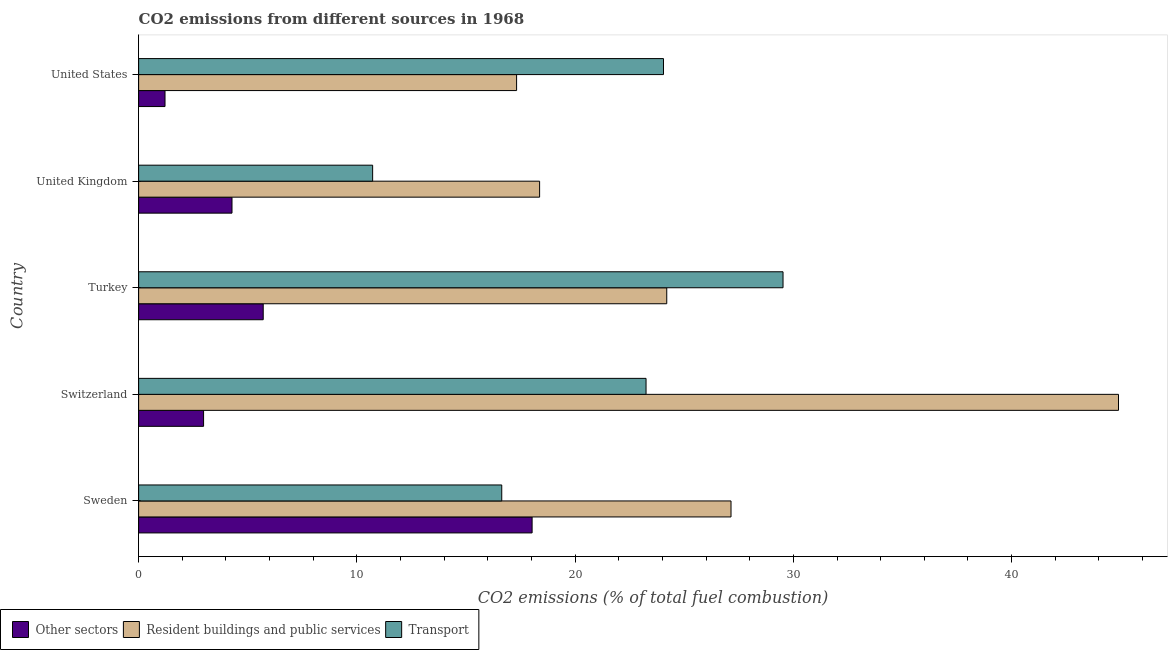Are the number of bars per tick equal to the number of legend labels?
Your answer should be very brief. Yes. What is the label of the 4th group of bars from the top?
Your answer should be compact. Switzerland. What is the percentage of co2 emissions from transport in United Kingdom?
Your response must be concise. 10.72. Across all countries, what is the maximum percentage of co2 emissions from transport?
Ensure brevity in your answer.  29.53. Across all countries, what is the minimum percentage of co2 emissions from other sectors?
Provide a succinct answer. 1.21. In which country was the percentage of co2 emissions from resident buildings and public services maximum?
Your answer should be compact. Switzerland. In which country was the percentage of co2 emissions from other sectors minimum?
Your response must be concise. United States. What is the total percentage of co2 emissions from other sectors in the graph?
Your answer should be compact. 32.2. What is the difference between the percentage of co2 emissions from transport in Turkey and that in United States?
Ensure brevity in your answer.  5.48. What is the difference between the percentage of co2 emissions from resident buildings and public services in Turkey and the percentage of co2 emissions from other sectors in United States?
Provide a short and direct response. 22.99. What is the average percentage of co2 emissions from resident buildings and public services per country?
Offer a terse response. 26.39. What is the difference between the percentage of co2 emissions from other sectors and percentage of co2 emissions from resident buildings and public services in Turkey?
Provide a succinct answer. -18.49. In how many countries, is the percentage of co2 emissions from transport greater than 26 %?
Keep it short and to the point. 1. What is the ratio of the percentage of co2 emissions from other sectors in Sweden to that in United Kingdom?
Make the answer very short. 4.21. Is the percentage of co2 emissions from transport in Sweden less than that in United States?
Your response must be concise. Yes. Is the difference between the percentage of co2 emissions from transport in Sweden and United States greater than the difference between the percentage of co2 emissions from other sectors in Sweden and United States?
Keep it short and to the point. No. What is the difference between the highest and the second highest percentage of co2 emissions from resident buildings and public services?
Offer a terse response. 17.75. What is the difference between the highest and the lowest percentage of co2 emissions from resident buildings and public services?
Offer a terse response. 27.58. In how many countries, is the percentage of co2 emissions from other sectors greater than the average percentage of co2 emissions from other sectors taken over all countries?
Offer a very short reply. 1. What does the 2nd bar from the top in Turkey represents?
Offer a very short reply. Resident buildings and public services. What does the 1st bar from the bottom in United States represents?
Keep it short and to the point. Other sectors. Is it the case that in every country, the sum of the percentage of co2 emissions from other sectors and percentage of co2 emissions from resident buildings and public services is greater than the percentage of co2 emissions from transport?
Your answer should be compact. No. How many bars are there?
Keep it short and to the point. 15. How are the legend labels stacked?
Provide a short and direct response. Horizontal. What is the title of the graph?
Your answer should be compact. CO2 emissions from different sources in 1968. Does "Natural gas sources" appear as one of the legend labels in the graph?
Keep it short and to the point. No. What is the label or title of the X-axis?
Ensure brevity in your answer.  CO2 emissions (% of total fuel combustion). What is the CO2 emissions (% of total fuel combustion) in Other sectors in Sweden?
Your answer should be compact. 18.03. What is the CO2 emissions (% of total fuel combustion) of Resident buildings and public services in Sweden?
Give a very brief answer. 27.14. What is the CO2 emissions (% of total fuel combustion) in Transport in Sweden?
Make the answer very short. 16.64. What is the CO2 emissions (% of total fuel combustion) of Other sectors in Switzerland?
Ensure brevity in your answer.  2.98. What is the CO2 emissions (% of total fuel combustion) of Resident buildings and public services in Switzerland?
Provide a short and direct response. 44.9. What is the CO2 emissions (% of total fuel combustion) of Transport in Switzerland?
Make the answer very short. 23.25. What is the CO2 emissions (% of total fuel combustion) in Other sectors in Turkey?
Your answer should be very brief. 5.71. What is the CO2 emissions (% of total fuel combustion) of Resident buildings and public services in Turkey?
Give a very brief answer. 24.2. What is the CO2 emissions (% of total fuel combustion) in Transport in Turkey?
Your answer should be very brief. 29.53. What is the CO2 emissions (% of total fuel combustion) in Other sectors in United Kingdom?
Provide a short and direct response. 4.28. What is the CO2 emissions (% of total fuel combustion) of Resident buildings and public services in United Kingdom?
Provide a short and direct response. 18.37. What is the CO2 emissions (% of total fuel combustion) in Transport in United Kingdom?
Provide a succinct answer. 10.72. What is the CO2 emissions (% of total fuel combustion) in Other sectors in United States?
Make the answer very short. 1.21. What is the CO2 emissions (% of total fuel combustion) in Resident buildings and public services in United States?
Ensure brevity in your answer.  17.32. What is the CO2 emissions (% of total fuel combustion) of Transport in United States?
Offer a terse response. 24.05. Across all countries, what is the maximum CO2 emissions (% of total fuel combustion) in Other sectors?
Provide a succinct answer. 18.03. Across all countries, what is the maximum CO2 emissions (% of total fuel combustion) of Resident buildings and public services?
Your answer should be very brief. 44.9. Across all countries, what is the maximum CO2 emissions (% of total fuel combustion) in Transport?
Offer a terse response. 29.53. Across all countries, what is the minimum CO2 emissions (% of total fuel combustion) in Other sectors?
Offer a terse response. 1.21. Across all countries, what is the minimum CO2 emissions (% of total fuel combustion) in Resident buildings and public services?
Make the answer very short. 17.32. Across all countries, what is the minimum CO2 emissions (% of total fuel combustion) in Transport?
Keep it short and to the point. 10.72. What is the total CO2 emissions (% of total fuel combustion) of Other sectors in the graph?
Keep it short and to the point. 32.2. What is the total CO2 emissions (% of total fuel combustion) of Resident buildings and public services in the graph?
Keep it short and to the point. 131.93. What is the total CO2 emissions (% of total fuel combustion) of Transport in the graph?
Provide a short and direct response. 104.19. What is the difference between the CO2 emissions (% of total fuel combustion) in Other sectors in Sweden and that in Switzerland?
Your answer should be very brief. 15.05. What is the difference between the CO2 emissions (% of total fuel combustion) in Resident buildings and public services in Sweden and that in Switzerland?
Your answer should be very brief. -17.75. What is the difference between the CO2 emissions (% of total fuel combustion) of Transport in Sweden and that in Switzerland?
Offer a very short reply. -6.61. What is the difference between the CO2 emissions (% of total fuel combustion) of Other sectors in Sweden and that in Turkey?
Provide a short and direct response. 12.32. What is the difference between the CO2 emissions (% of total fuel combustion) of Resident buildings and public services in Sweden and that in Turkey?
Give a very brief answer. 2.94. What is the difference between the CO2 emissions (% of total fuel combustion) of Transport in Sweden and that in Turkey?
Make the answer very short. -12.89. What is the difference between the CO2 emissions (% of total fuel combustion) in Other sectors in Sweden and that in United Kingdom?
Your response must be concise. 13.75. What is the difference between the CO2 emissions (% of total fuel combustion) of Resident buildings and public services in Sweden and that in United Kingdom?
Make the answer very short. 8.77. What is the difference between the CO2 emissions (% of total fuel combustion) of Transport in Sweden and that in United Kingdom?
Your response must be concise. 5.92. What is the difference between the CO2 emissions (% of total fuel combustion) in Other sectors in Sweden and that in United States?
Offer a terse response. 16.82. What is the difference between the CO2 emissions (% of total fuel combustion) in Resident buildings and public services in Sweden and that in United States?
Your response must be concise. 9.82. What is the difference between the CO2 emissions (% of total fuel combustion) in Transport in Sweden and that in United States?
Your answer should be compact. -7.41. What is the difference between the CO2 emissions (% of total fuel combustion) of Other sectors in Switzerland and that in Turkey?
Your answer should be compact. -2.73. What is the difference between the CO2 emissions (% of total fuel combustion) in Resident buildings and public services in Switzerland and that in Turkey?
Ensure brevity in your answer.  20.7. What is the difference between the CO2 emissions (% of total fuel combustion) in Transport in Switzerland and that in Turkey?
Your answer should be compact. -6.28. What is the difference between the CO2 emissions (% of total fuel combustion) in Other sectors in Switzerland and that in United Kingdom?
Provide a short and direct response. -1.3. What is the difference between the CO2 emissions (% of total fuel combustion) in Resident buildings and public services in Switzerland and that in United Kingdom?
Give a very brief answer. 26.52. What is the difference between the CO2 emissions (% of total fuel combustion) in Transport in Switzerland and that in United Kingdom?
Offer a very short reply. 12.53. What is the difference between the CO2 emissions (% of total fuel combustion) of Other sectors in Switzerland and that in United States?
Offer a terse response. 1.77. What is the difference between the CO2 emissions (% of total fuel combustion) in Resident buildings and public services in Switzerland and that in United States?
Offer a terse response. 27.58. What is the difference between the CO2 emissions (% of total fuel combustion) in Transport in Switzerland and that in United States?
Your answer should be very brief. -0.8. What is the difference between the CO2 emissions (% of total fuel combustion) in Other sectors in Turkey and that in United Kingdom?
Provide a short and direct response. 1.43. What is the difference between the CO2 emissions (% of total fuel combustion) in Resident buildings and public services in Turkey and that in United Kingdom?
Keep it short and to the point. 5.83. What is the difference between the CO2 emissions (% of total fuel combustion) in Transport in Turkey and that in United Kingdom?
Provide a short and direct response. 18.8. What is the difference between the CO2 emissions (% of total fuel combustion) in Other sectors in Turkey and that in United States?
Provide a short and direct response. 4.5. What is the difference between the CO2 emissions (% of total fuel combustion) of Resident buildings and public services in Turkey and that in United States?
Provide a succinct answer. 6.88. What is the difference between the CO2 emissions (% of total fuel combustion) in Transport in Turkey and that in United States?
Make the answer very short. 5.48. What is the difference between the CO2 emissions (% of total fuel combustion) in Other sectors in United Kingdom and that in United States?
Your response must be concise. 3.07. What is the difference between the CO2 emissions (% of total fuel combustion) in Resident buildings and public services in United Kingdom and that in United States?
Provide a short and direct response. 1.05. What is the difference between the CO2 emissions (% of total fuel combustion) of Transport in United Kingdom and that in United States?
Your answer should be very brief. -13.33. What is the difference between the CO2 emissions (% of total fuel combustion) of Other sectors in Sweden and the CO2 emissions (% of total fuel combustion) of Resident buildings and public services in Switzerland?
Your answer should be compact. -26.87. What is the difference between the CO2 emissions (% of total fuel combustion) of Other sectors in Sweden and the CO2 emissions (% of total fuel combustion) of Transport in Switzerland?
Your answer should be very brief. -5.22. What is the difference between the CO2 emissions (% of total fuel combustion) of Resident buildings and public services in Sweden and the CO2 emissions (% of total fuel combustion) of Transport in Switzerland?
Offer a very short reply. 3.89. What is the difference between the CO2 emissions (% of total fuel combustion) in Other sectors in Sweden and the CO2 emissions (% of total fuel combustion) in Resident buildings and public services in Turkey?
Make the answer very short. -6.17. What is the difference between the CO2 emissions (% of total fuel combustion) of Other sectors in Sweden and the CO2 emissions (% of total fuel combustion) of Transport in Turkey?
Your response must be concise. -11.5. What is the difference between the CO2 emissions (% of total fuel combustion) of Resident buildings and public services in Sweden and the CO2 emissions (% of total fuel combustion) of Transport in Turkey?
Your response must be concise. -2.38. What is the difference between the CO2 emissions (% of total fuel combustion) of Other sectors in Sweden and the CO2 emissions (% of total fuel combustion) of Resident buildings and public services in United Kingdom?
Offer a terse response. -0.34. What is the difference between the CO2 emissions (% of total fuel combustion) in Other sectors in Sweden and the CO2 emissions (% of total fuel combustion) in Transport in United Kingdom?
Provide a short and direct response. 7.31. What is the difference between the CO2 emissions (% of total fuel combustion) of Resident buildings and public services in Sweden and the CO2 emissions (% of total fuel combustion) of Transport in United Kingdom?
Ensure brevity in your answer.  16.42. What is the difference between the CO2 emissions (% of total fuel combustion) of Other sectors in Sweden and the CO2 emissions (% of total fuel combustion) of Resident buildings and public services in United States?
Ensure brevity in your answer.  0.71. What is the difference between the CO2 emissions (% of total fuel combustion) of Other sectors in Sweden and the CO2 emissions (% of total fuel combustion) of Transport in United States?
Provide a succinct answer. -6.02. What is the difference between the CO2 emissions (% of total fuel combustion) in Resident buildings and public services in Sweden and the CO2 emissions (% of total fuel combustion) in Transport in United States?
Provide a succinct answer. 3.09. What is the difference between the CO2 emissions (% of total fuel combustion) in Other sectors in Switzerland and the CO2 emissions (% of total fuel combustion) in Resident buildings and public services in Turkey?
Give a very brief answer. -21.22. What is the difference between the CO2 emissions (% of total fuel combustion) in Other sectors in Switzerland and the CO2 emissions (% of total fuel combustion) in Transport in Turkey?
Keep it short and to the point. -26.55. What is the difference between the CO2 emissions (% of total fuel combustion) of Resident buildings and public services in Switzerland and the CO2 emissions (% of total fuel combustion) of Transport in Turkey?
Offer a terse response. 15.37. What is the difference between the CO2 emissions (% of total fuel combustion) in Other sectors in Switzerland and the CO2 emissions (% of total fuel combustion) in Resident buildings and public services in United Kingdom?
Your response must be concise. -15.4. What is the difference between the CO2 emissions (% of total fuel combustion) in Other sectors in Switzerland and the CO2 emissions (% of total fuel combustion) in Transport in United Kingdom?
Keep it short and to the point. -7.75. What is the difference between the CO2 emissions (% of total fuel combustion) of Resident buildings and public services in Switzerland and the CO2 emissions (% of total fuel combustion) of Transport in United Kingdom?
Keep it short and to the point. 34.18. What is the difference between the CO2 emissions (% of total fuel combustion) in Other sectors in Switzerland and the CO2 emissions (% of total fuel combustion) in Resident buildings and public services in United States?
Provide a short and direct response. -14.34. What is the difference between the CO2 emissions (% of total fuel combustion) in Other sectors in Switzerland and the CO2 emissions (% of total fuel combustion) in Transport in United States?
Your answer should be very brief. -21.07. What is the difference between the CO2 emissions (% of total fuel combustion) in Resident buildings and public services in Switzerland and the CO2 emissions (% of total fuel combustion) in Transport in United States?
Offer a terse response. 20.85. What is the difference between the CO2 emissions (% of total fuel combustion) in Other sectors in Turkey and the CO2 emissions (% of total fuel combustion) in Resident buildings and public services in United Kingdom?
Provide a succinct answer. -12.66. What is the difference between the CO2 emissions (% of total fuel combustion) of Other sectors in Turkey and the CO2 emissions (% of total fuel combustion) of Transport in United Kingdom?
Offer a terse response. -5.01. What is the difference between the CO2 emissions (% of total fuel combustion) in Resident buildings and public services in Turkey and the CO2 emissions (% of total fuel combustion) in Transport in United Kingdom?
Provide a succinct answer. 13.48. What is the difference between the CO2 emissions (% of total fuel combustion) in Other sectors in Turkey and the CO2 emissions (% of total fuel combustion) in Resident buildings and public services in United States?
Keep it short and to the point. -11.61. What is the difference between the CO2 emissions (% of total fuel combustion) of Other sectors in Turkey and the CO2 emissions (% of total fuel combustion) of Transport in United States?
Your answer should be compact. -18.34. What is the difference between the CO2 emissions (% of total fuel combustion) in Resident buildings and public services in Turkey and the CO2 emissions (% of total fuel combustion) in Transport in United States?
Ensure brevity in your answer.  0.15. What is the difference between the CO2 emissions (% of total fuel combustion) in Other sectors in United Kingdom and the CO2 emissions (% of total fuel combustion) in Resident buildings and public services in United States?
Offer a terse response. -13.04. What is the difference between the CO2 emissions (% of total fuel combustion) in Other sectors in United Kingdom and the CO2 emissions (% of total fuel combustion) in Transport in United States?
Your answer should be compact. -19.77. What is the difference between the CO2 emissions (% of total fuel combustion) of Resident buildings and public services in United Kingdom and the CO2 emissions (% of total fuel combustion) of Transport in United States?
Your answer should be compact. -5.68. What is the average CO2 emissions (% of total fuel combustion) in Other sectors per country?
Offer a terse response. 6.44. What is the average CO2 emissions (% of total fuel combustion) of Resident buildings and public services per country?
Offer a very short reply. 26.39. What is the average CO2 emissions (% of total fuel combustion) in Transport per country?
Provide a short and direct response. 20.84. What is the difference between the CO2 emissions (% of total fuel combustion) in Other sectors and CO2 emissions (% of total fuel combustion) in Resident buildings and public services in Sweden?
Provide a succinct answer. -9.11. What is the difference between the CO2 emissions (% of total fuel combustion) of Other sectors and CO2 emissions (% of total fuel combustion) of Transport in Sweden?
Provide a short and direct response. 1.39. What is the difference between the CO2 emissions (% of total fuel combustion) in Resident buildings and public services and CO2 emissions (% of total fuel combustion) in Transport in Sweden?
Offer a terse response. 10.51. What is the difference between the CO2 emissions (% of total fuel combustion) of Other sectors and CO2 emissions (% of total fuel combustion) of Resident buildings and public services in Switzerland?
Give a very brief answer. -41.92. What is the difference between the CO2 emissions (% of total fuel combustion) of Other sectors and CO2 emissions (% of total fuel combustion) of Transport in Switzerland?
Your response must be concise. -20.27. What is the difference between the CO2 emissions (% of total fuel combustion) of Resident buildings and public services and CO2 emissions (% of total fuel combustion) of Transport in Switzerland?
Provide a short and direct response. 21.65. What is the difference between the CO2 emissions (% of total fuel combustion) of Other sectors and CO2 emissions (% of total fuel combustion) of Resident buildings and public services in Turkey?
Your answer should be compact. -18.49. What is the difference between the CO2 emissions (% of total fuel combustion) of Other sectors and CO2 emissions (% of total fuel combustion) of Transport in Turkey?
Your answer should be compact. -23.82. What is the difference between the CO2 emissions (% of total fuel combustion) in Resident buildings and public services and CO2 emissions (% of total fuel combustion) in Transport in Turkey?
Offer a very short reply. -5.33. What is the difference between the CO2 emissions (% of total fuel combustion) of Other sectors and CO2 emissions (% of total fuel combustion) of Resident buildings and public services in United Kingdom?
Make the answer very short. -14.1. What is the difference between the CO2 emissions (% of total fuel combustion) of Other sectors and CO2 emissions (% of total fuel combustion) of Transport in United Kingdom?
Keep it short and to the point. -6.44. What is the difference between the CO2 emissions (% of total fuel combustion) of Resident buildings and public services and CO2 emissions (% of total fuel combustion) of Transport in United Kingdom?
Give a very brief answer. 7.65. What is the difference between the CO2 emissions (% of total fuel combustion) in Other sectors and CO2 emissions (% of total fuel combustion) in Resident buildings and public services in United States?
Keep it short and to the point. -16.11. What is the difference between the CO2 emissions (% of total fuel combustion) in Other sectors and CO2 emissions (% of total fuel combustion) in Transport in United States?
Keep it short and to the point. -22.84. What is the difference between the CO2 emissions (% of total fuel combustion) in Resident buildings and public services and CO2 emissions (% of total fuel combustion) in Transport in United States?
Provide a short and direct response. -6.73. What is the ratio of the CO2 emissions (% of total fuel combustion) of Other sectors in Sweden to that in Switzerland?
Give a very brief answer. 6.06. What is the ratio of the CO2 emissions (% of total fuel combustion) of Resident buildings and public services in Sweden to that in Switzerland?
Provide a short and direct response. 0.6. What is the ratio of the CO2 emissions (% of total fuel combustion) in Transport in Sweden to that in Switzerland?
Provide a succinct answer. 0.72. What is the ratio of the CO2 emissions (% of total fuel combustion) of Other sectors in Sweden to that in Turkey?
Give a very brief answer. 3.16. What is the ratio of the CO2 emissions (% of total fuel combustion) of Resident buildings and public services in Sweden to that in Turkey?
Give a very brief answer. 1.12. What is the ratio of the CO2 emissions (% of total fuel combustion) in Transport in Sweden to that in Turkey?
Your response must be concise. 0.56. What is the ratio of the CO2 emissions (% of total fuel combustion) in Other sectors in Sweden to that in United Kingdom?
Offer a very short reply. 4.21. What is the ratio of the CO2 emissions (% of total fuel combustion) in Resident buildings and public services in Sweden to that in United Kingdom?
Keep it short and to the point. 1.48. What is the ratio of the CO2 emissions (% of total fuel combustion) of Transport in Sweden to that in United Kingdom?
Make the answer very short. 1.55. What is the ratio of the CO2 emissions (% of total fuel combustion) of Other sectors in Sweden to that in United States?
Your response must be concise. 14.91. What is the ratio of the CO2 emissions (% of total fuel combustion) in Resident buildings and public services in Sweden to that in United States?
Make the answer very short. 1.57. What is the ratio of the CO2 emissions (% of total fuel combustion) of Transport in Sweden to that in United States?
Ensure brevity in your answer.  0.69. What is the ratio of the CO2 emissions (% of total fuel combustion) in Other sectors in Switzerland to that in Turkey?
Your answer should be very brief. 0.52. What is the ratio of the CO2 emissions (% of total fuel combustion) of Resident buildings and public services in Switzerland to that in Turkey?
Keep it short and to the point. 1.86. What is the ratio of the CO2 emissions (% of total fuel combustion) of Transport in Switzerland to that in Turkey?
Offer a terse response. 0.79. What is the ratio of the CO2 emissions (% of total fuel combustion) in Other sectors in Switzerland to that in United Kingdom?
Provide a succinct answer. 0.7. What is the ratio of the CO2 emissions (% of total fuel combustion) of Resident buildings and public services in Switzerland to that in United Kingdom?
Keep it short and to the point. 2.44. What is the ratio of the CO2 emissions (% of total fuel combustion) in Transport in Switzerland to that in United Kingdom?
Keep it short and to the point. 2.17. What is the ratio of the CO2 emissions (% of total fuel combustion) of Other sectors in Switzerland to that in United States?
Offer a terse response. 2.46. What is the ratio of the CO2 emissions (% of total fuel combustion) of Resident buildings and public services in Switzerland to that in United States?
Provide a succinct answer. 2.59. What is the ratio of the CO2 emissions (% of total fuel combustion) in Transport in Switzerland to that in United States?
Offer a terse response. 0.97. What is the ratio of the CO2 emissions (% of total fuel combustion) in Other sectors in Turkey to that in United Kingdom?
Provide a short and direct response. 1.33. What is the ratio of the CO2 emissions (% of total fuel combustion) in Resident buildings and public services in Turkey to that in United Kingdom?
Ensure brevity in your answer.  1.32. What is the ratio of the CO2 emissions (% of total fuel combustion) in Transport in Turkey to that in United Kingdom?
Give a very brief answer. 2.75. What is the ratio of the CO2 emissions (% of total fuel combustion) of Other sectors in Turkey to that in United States?
Offer a very short reply. 4.72. What is the ratio of the CO2 emissions (% of total fuel combustion) of Resident buildings and public services in Turkey to that in United States?
Your answer should be compact. 1.4. What is the ratio of the CO2 emissions (% of total fuel combustion) of Transport in Turkey to that in United States?
Your response must be concise. 1.23. What is the ratio of the CO2 emissions (% of total fuel combustion) in Other sectors in United Kingdom to that in United States?
Give a very brief answer. 3.54. What is the ratio of the CO2 emissions (% of total fuel combustion) in Resident buildings and public services in United Kingdom to that in United States?
Your response must be concise. 1.06. What is the ratio of the CO2 emissions (% of total fuel combustion) in Transport in United Kingdom to that in United States?
Your answer should be compact. 0.45. What is the difference between the highest and the second highest CO2 emissions (% of total fuel combustion) of Other sectors?
Provide a succinct answer. 12.32. What is the difference between the highest and the second highest CO2 emissions (% of total fuel combustion) of Resident buildings and public services?
Offer a terse response. 17.75. What is the difference between the highest and the second highest CO2 emissions (% of total fuel combustion) in Transport?
Keep it short and to the point. 5.48. What is the difference between the highest and the lowest CO2 emissions (% of total fuel combustion) of Other sectors?
Offer a very short reply. 16.82. What is the difference between the highest and the lowest CO2 emissions (% of total fuel combustion) of Resident buildings and public services?
Provide a short and direct response. 27.58. What is the difference between the highest and the lowest CO2 emissions (% of total fuel combustion) in Transport?
Provide a succinct answer. 18.8. 